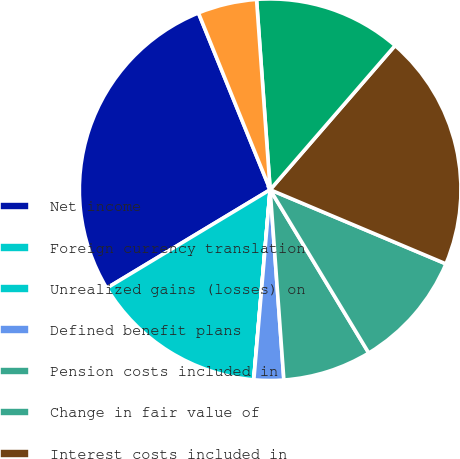Convert chart to OTSL. <chart><loc_0><loc_0><loc_500><loc_500><pie_chart><fcel>Net income<fcel>Foreign currency translation<fcel>Unrealized gains (losses) on<fcel>Defined benefit plans<fcel>Pension costs included in<fcel>Change in fair value of<fcel>Interest costs included in<fcel>Other comprehensive income<fcel>Income taxes (benefits)<nl><fcel>27.49%<fcel>15.0%<fcel>0.01%<fcel>2.51%<fcel>7.5%<fcel>10.0%<fcel>19.99%<fcel>12.5%<fcel>5.0%<nl></chart> 